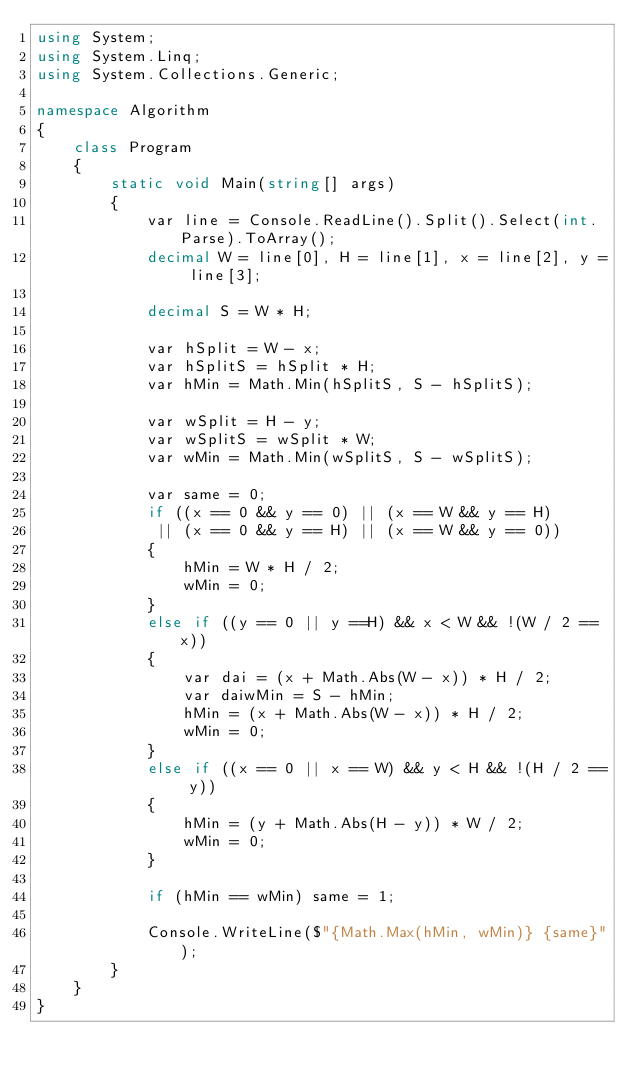<code> <loc_0><loc_0><loc_500><loc_500><_C#_>using System;
using System.Linq;
using System.Collections.Generic;

namespace Algorithm
{
    class Program
    {
        static void Main(string[] args)
        {
            var line = Console.ReadLine().Split().Select(int.Parse).ToArray();
            decimal W = line[0], H = line[1], x = line[2], y = line[3];

            decimal S = W * H;

            var hSplit = W - x;
            var hSplitS = hSplit * H;
            var hMin = Math.Min(hSplitS, S - hSplitS);

            var wSplit = H - y;
            var wSplitS = wSplit * W;
            var wMin = Math.Min(wSplitS, S - wSplitS);

            var same = 0;
            if ((x == 0 && y == 0) || (x == W && y == H)
             || (x == 0 && y == H) || (x == W && y == 0))
            {
                hMin = W * H / 2;
                wMin = 0;
            }
            else if ((y == 0 || y ==H) && x < W && !(W / 2 == x))
            {
                var dai = (x + Math.Abs(W - x)) * H / 2;
                var daiwMin = S - hMin;
                hMin = (x + Math.Abs(W - x)) * H / 2;
                wMin = 0;
            }
            else if ((x == 0 || x == W) && y < H && !(H / 2 == y))
            {
                hMin = (y + Math.Abs(H - y)) * W / 2;
                wMin = 0;
            }

            if (hMin == wMin) same = 1;

            Console.WriteLine($"{Math.Max(hMin, wMin)} {same}");
        }
    }
}
</code> 